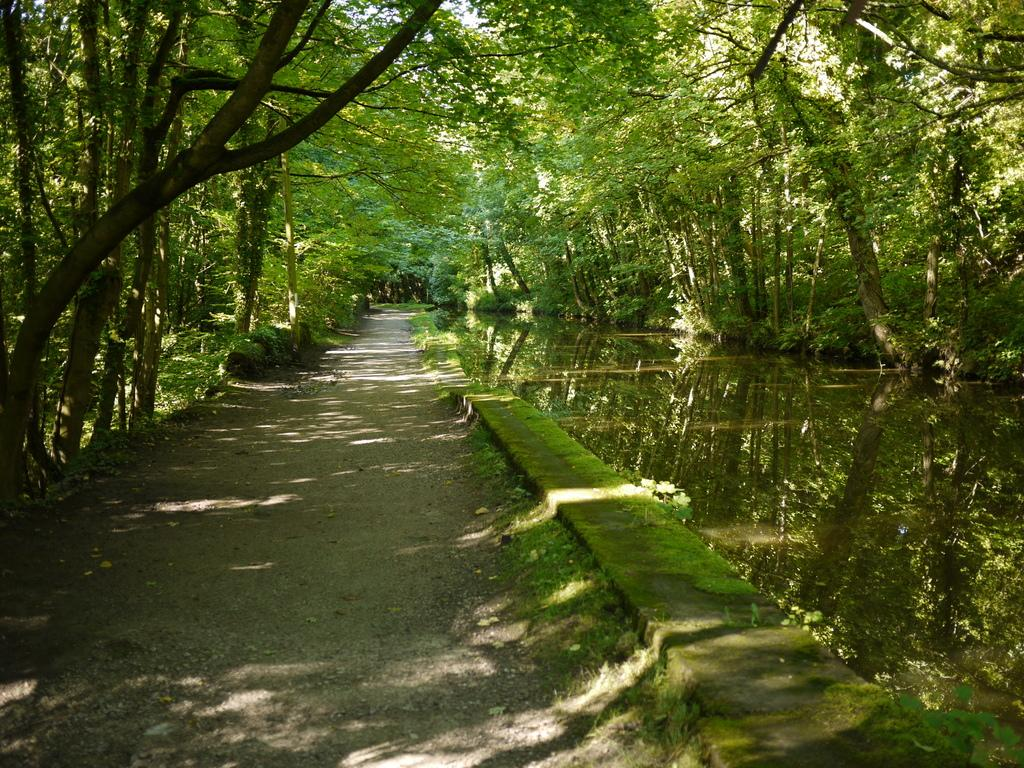What type of vegetation can be seen in the image? There are trees, plants, and grass visible in the image. What man-made structure is present in the image? There is a road in the image. Can you see any frogs or hens wearing trousers in the image? There are no frogs, hens, or trousers present in the image. 